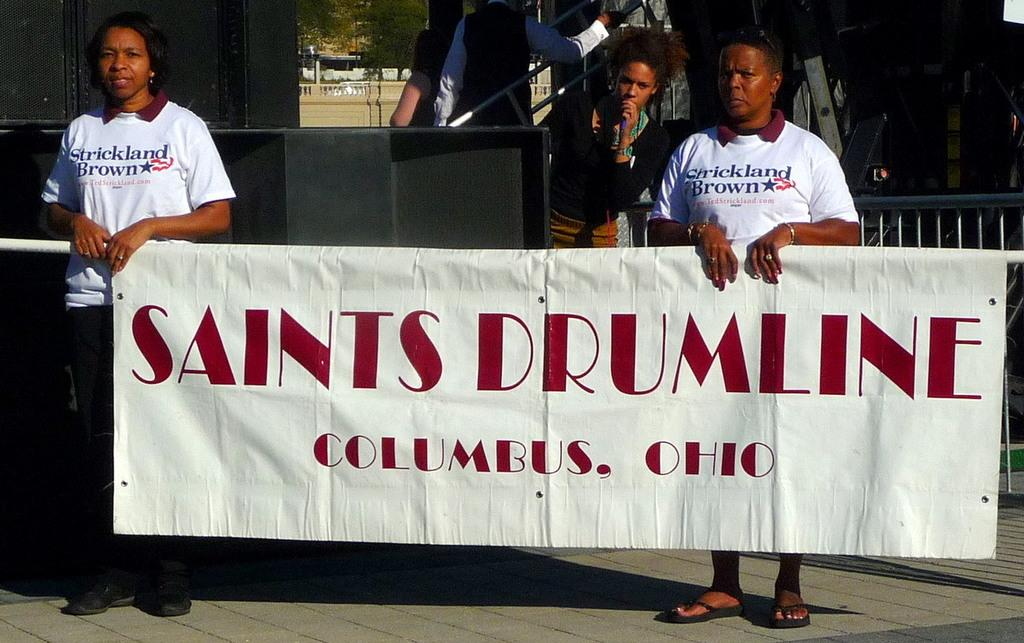<image>
Relay a brief, clear account of the picture shown. two people holding up a sign that says saints drumline columbus, ohio 